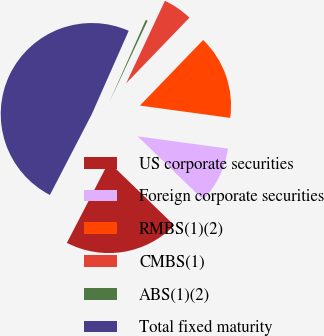Convert chart. <chart><loc_0><loc_0><loc_500><loc_500><pie_chart><fcel>US corporate securities<fcel>Foreign corporate securities<fcel>RMBS(1)(2)<fcel>CMBS(1)<fcel>ABS(1)(2)<fcel>Total fixed maturity<nl><fcel>20.37%<fcel>10.08%<fcel>14.95%<fcel>5.22%<fcel>0.35%<fcel>49.03%<nl></chart> 